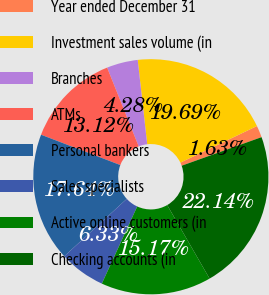<chart> <loc_0><loc_0><loc_500><loc_500><pie_chart><fcel>Year ended December 31<fcel>Investment sales volume (in<fcel>Branches<fcel>ATMs<fcel>Personal bankers<fcel>Sales specialists<fcel>Active online customers (in<fcel>Checking accounts (in<nl><fcel>1.63%<fcel>19.69%<fcel>4.28%<fcel>13.12%<fcel>17.64%<fcel>6.33%<fcel>15.17%<fcel>22.14%<nl></chart> 